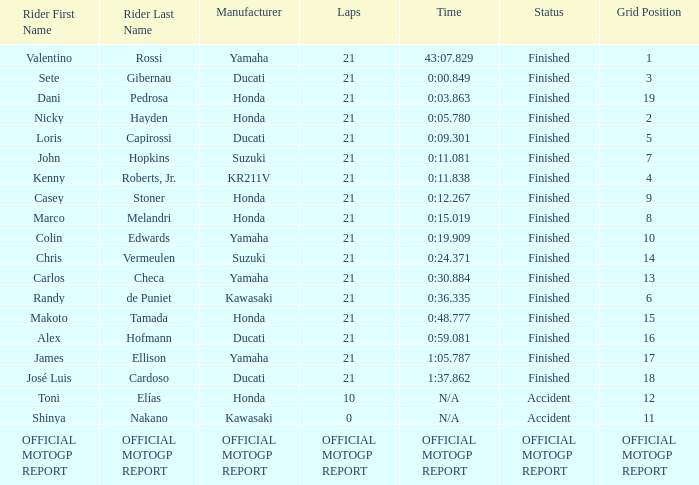Which rider had a time/retired od +19.909? Colin Edwards. 